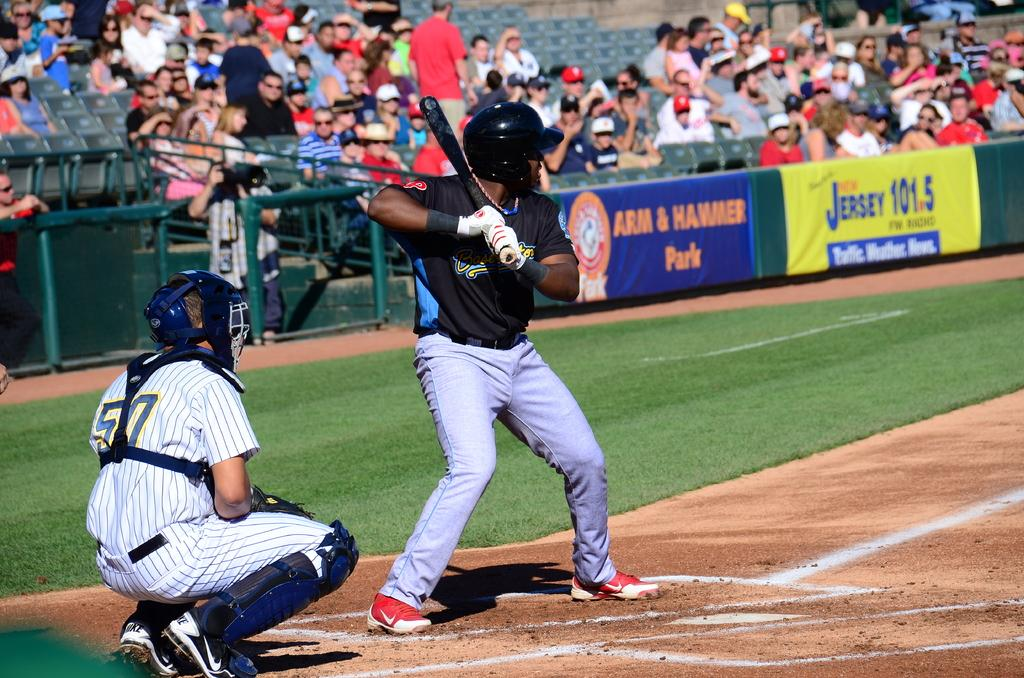<image>
Provide a brief description of the given image. The player with number 57 sits behind the person about to strike the ball. 